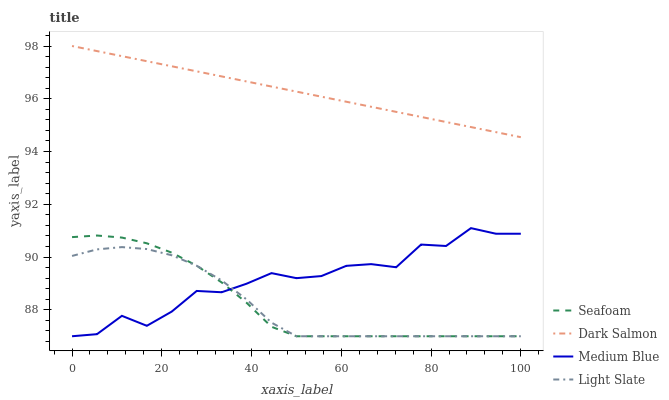Does Light Slate have the minimum area under the curve?
Answer yes or no. Yes. Does Dark Salmon have the maximum area under the curve?
Answer yes or no. Yes. Does Medium Blue have the minimum area under the curve?
Answer yes or no. No. Does Medium Blue have the maximum area under the curve?
Answer yes or no. No. Is Dark Salmon the smoothest?
Answer yes or no. Yes. Is Medium Blue the roughest?
Answer yes or no. Yes. Is Seafoam the smoothest?
Answer yes or no. No. Is Seafoam the roughest?
Answer yes or no. No. Does Light Slate have the lowest value?
Answer yes or no. Yes. Does Dark Salmon have the lowest value?
Answer yes or no. No. Does Dark Salmon have the highest value?
Answer yes or no. Yes. Does Medium Blue have the highest value?
Answer yes or no. No. Is Medium Blue less than Dark Salmon?
Answer yes or no. Yes. Is Dark Salmon greater than Medium Blue?
Answer yes or no. Yes. Does Light Slate intersect Seafoam?
Answer yes or no. Yes. Is Light Slate less than Seafoam?
Answer yes or no. No. Is Light Slate greater than Seafoam?
Answer yes or no. No. Does Medium Blue intersect Dark Salmon?
Answer yes or no. No. 